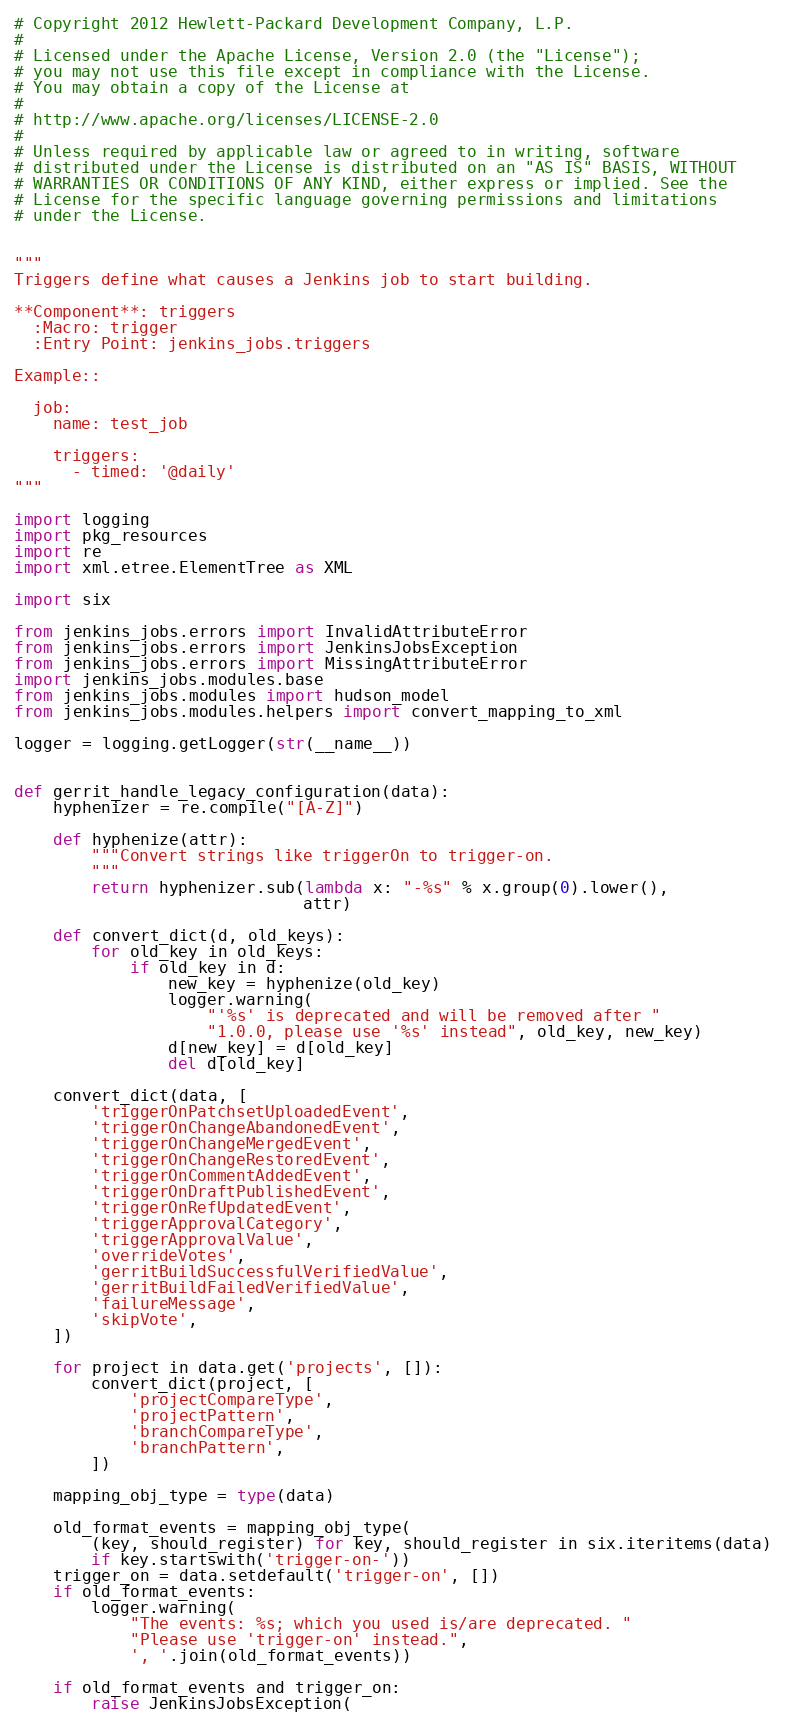Convert code to text. <code><loc_0><loc_0><loc_500><loc_500><_Python_># Copyright 2012 Hewlett-Packard Development Company, L.P.
#
# Licensed under the Apache License, Version 2.0 (the "License");
# you may not use this file except in compliance with the License.
# You may obtain a copy of the License at
#
# http://www.apache.org/licenses/LICENSE-2.0
#
# Unless required by applicable law or agreed to in writing, software
# distributed under the License is distributed on an "AS IS" BASIS, WITHOUT
# WARRANTIES OR CONDITIONS OF ANY KIND, either express or implied. See the
# License for the specific language governing permissions and limitations
# under the License.


"""
Triggers define what causes a Jenkins job to start building.

**Component**: triggers
  :Macro: trigger
  :Entry Point: jenkins_jobs.triggers

Example::

  job:
    name: test_job

    triggers:
      - timed: '@daily'
"""

import logging
import pkg_resources
import re
import xml.etree.ElementTree as XML

import six

from jenkins_jobs.errors import InvalidAttributeError
from jenkins_jobs.errors import JenkinsJobsException
from jenkins_jobs.errors import MissingAttributeError
import jenkins_jobs.modules.base
from jenkins_jobs.modules import hudson_model
from jenkins_jobs.modules.helpers import convert_mapping_to_xml

logger = logging.getLogger(str(__name__))


def gerrit_handle_legacy_configuration(data):
    hyphenizer = re.compile("[A-Z]")

    def hyphenize(attr):
        """Convert strings like triggerOn to trigger-on.
        """
        return hyphenizer.sub(lambda x: "-%s" % x.group(0).lower(),
                              attr)

    def convert_dict(d, old_keys):
        for old_key in old_keys:
            if old_key in d:
                new_key = hyphenize(old_key)
                logger.warning(
                    "'%s' is deprecated and will be removed after "
                    "1.0.0, please use '%s' instead", old_key, new_key)
                d[new_key] = d[old_key]
                del d[old_key]

    convert_dict(data, [
        'triggerOnPatchsetUploadedEvent',
        'triggerOnChangeAbandonedEvent',
        'triggerOnChangeMergedEvent',
        'triggerOnChangeRestoredEvent',
        'triggerOnCommentAddedEvent',
        'triggerOnDraftPublishedEvent',
        'triggerOnRefUpdatedEvent',
        'triggerApprovalCategory',
        'triggerApprovalValue',
        'overrideVotes',
        'gerritBuildSuccessfulVerifiedValue',
        'gerritBuildFailedVerifiedValue',
        'failureMessage',
        'skipVote',
    ])

    for project in data.get('projects', []):
        convert_dict(project, [
            'projectCompareType',
            'projectPattern',
            'branchCompareType',
            'branchPattern',
        ])

    mapping_obj_type = type(data)

    old_format_events = mapping_obj_type(
        (key, should_register) for key, should_register in six.iteritems(data)
        if key.startswith('trigger-on-'))
    trigger_on = data.setdefault('trigger-on', [])
    if old_format_events:
        logger.warning(
            "The events: %s; which you used is/are deprecated. "
            "Please use 'trigger-on' instead.",
            ', '.join(old_format_events))

    if old_format_events and trigger_on:
        raise JenkinsJobsException(</code> 